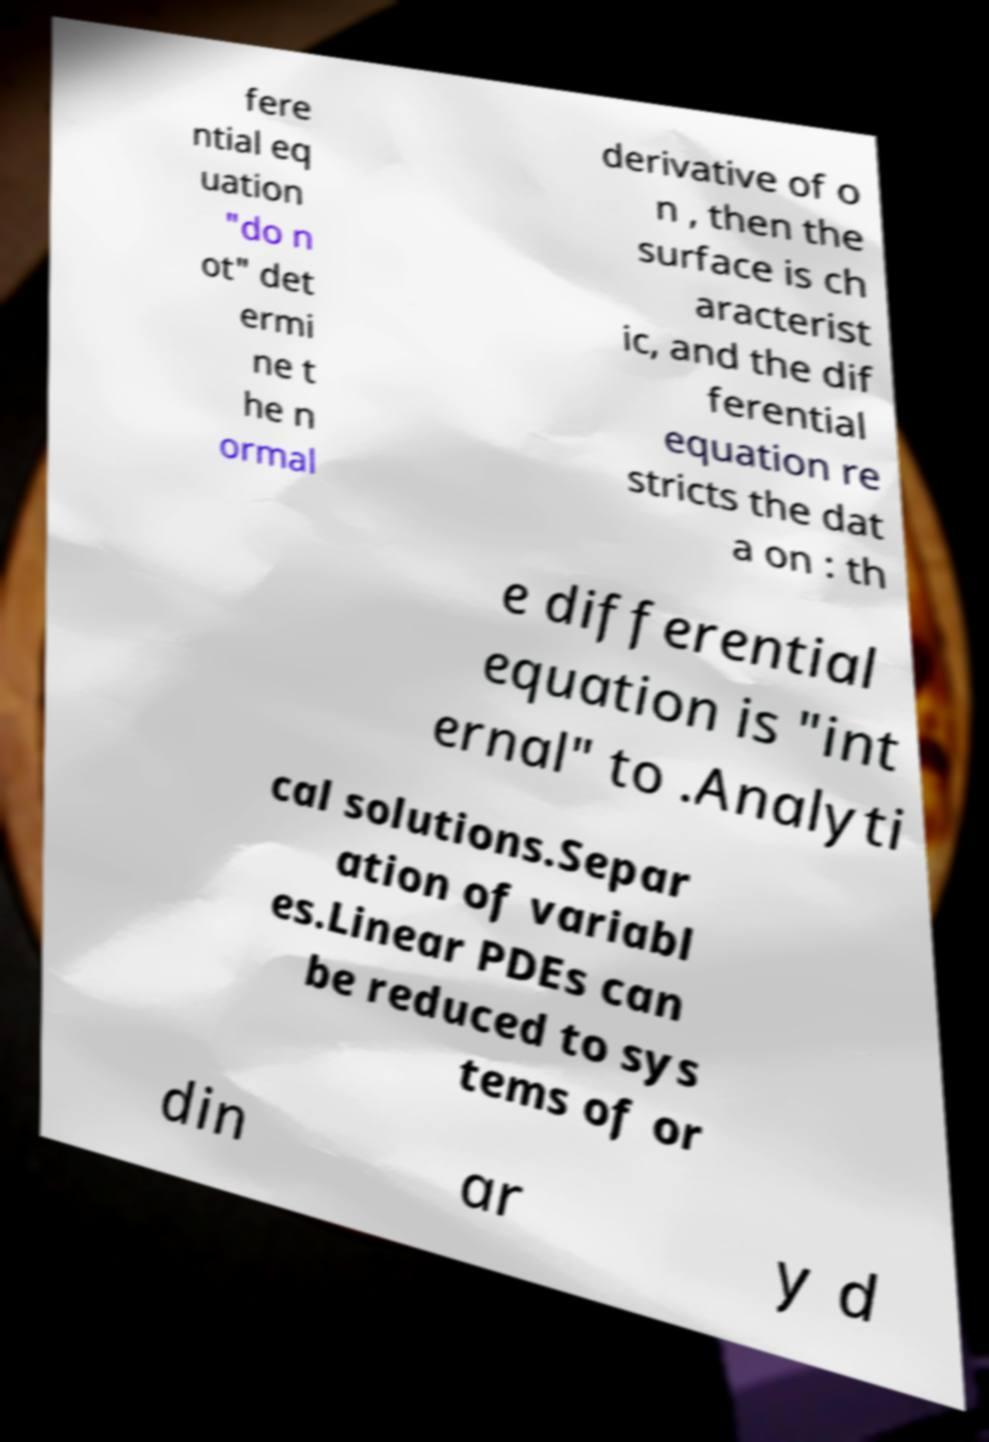Could you extract and type out the text from this image? fere ntial eq uation "do n ot" det ermi ne t he n ormal derivative of o n , then the surface is ch aracterist ic, and the dif ferential equation re stricts the dat a on : th e differential equation is "int ernal" to .Analyti cal solutions.Separ ation of variabl es.Linear PDEs can be reduced to sys tems of or din ar y d 